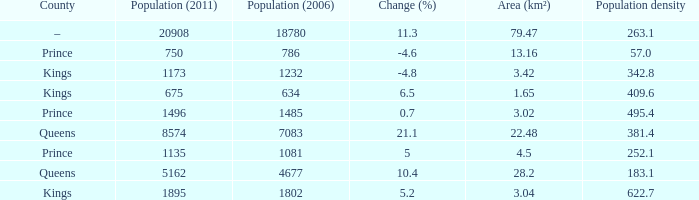What was the Area (km²) when the Population (2011) was 8574, and the Population density was larger than 381.4? None. 